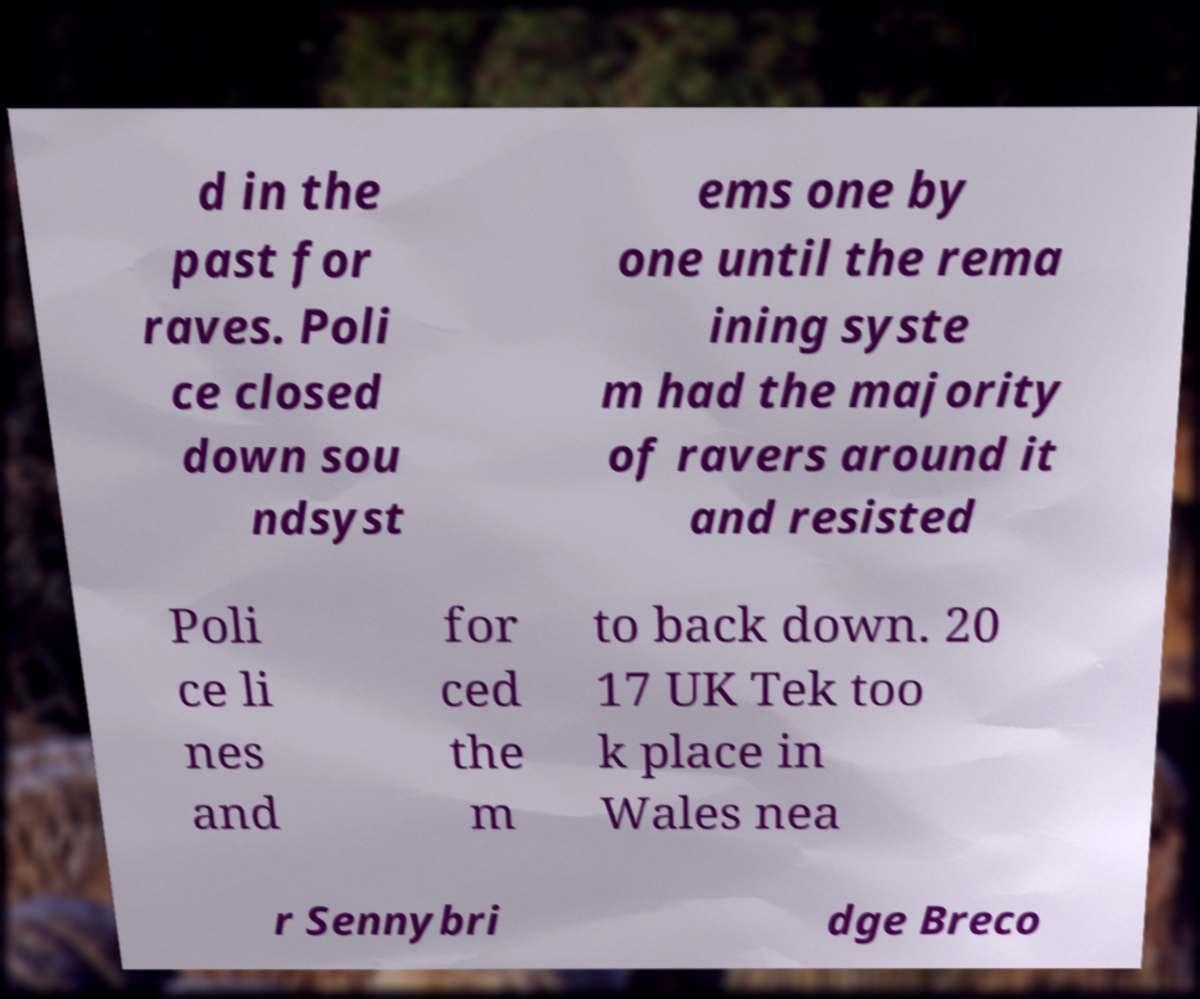Please read and relay the text visible in this image. What does it say? d in the past for raves. Poli ce closed down sou ndsyst ems one by one until the rema ining syste m had the majority of ravers around it and resisted Poli ce li nes and for ced the m to back down. 20 17 UK Tek too k place in Wales nea r Sennybri dge Breco 